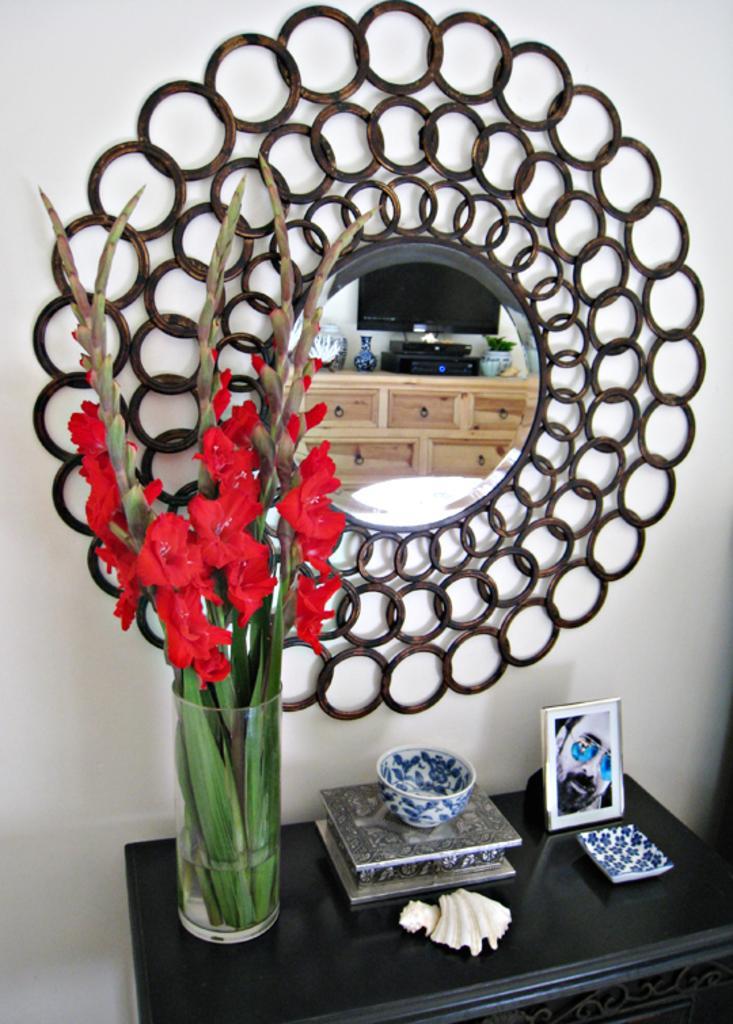Please provide a concise description of this image. The picture consists of desk, bowl, frame flower vase, glass, mirror and other objects. The wall is painted white. In the mirror we can see the reflection of television, flower vase, aquarium, drawers and other objects. 